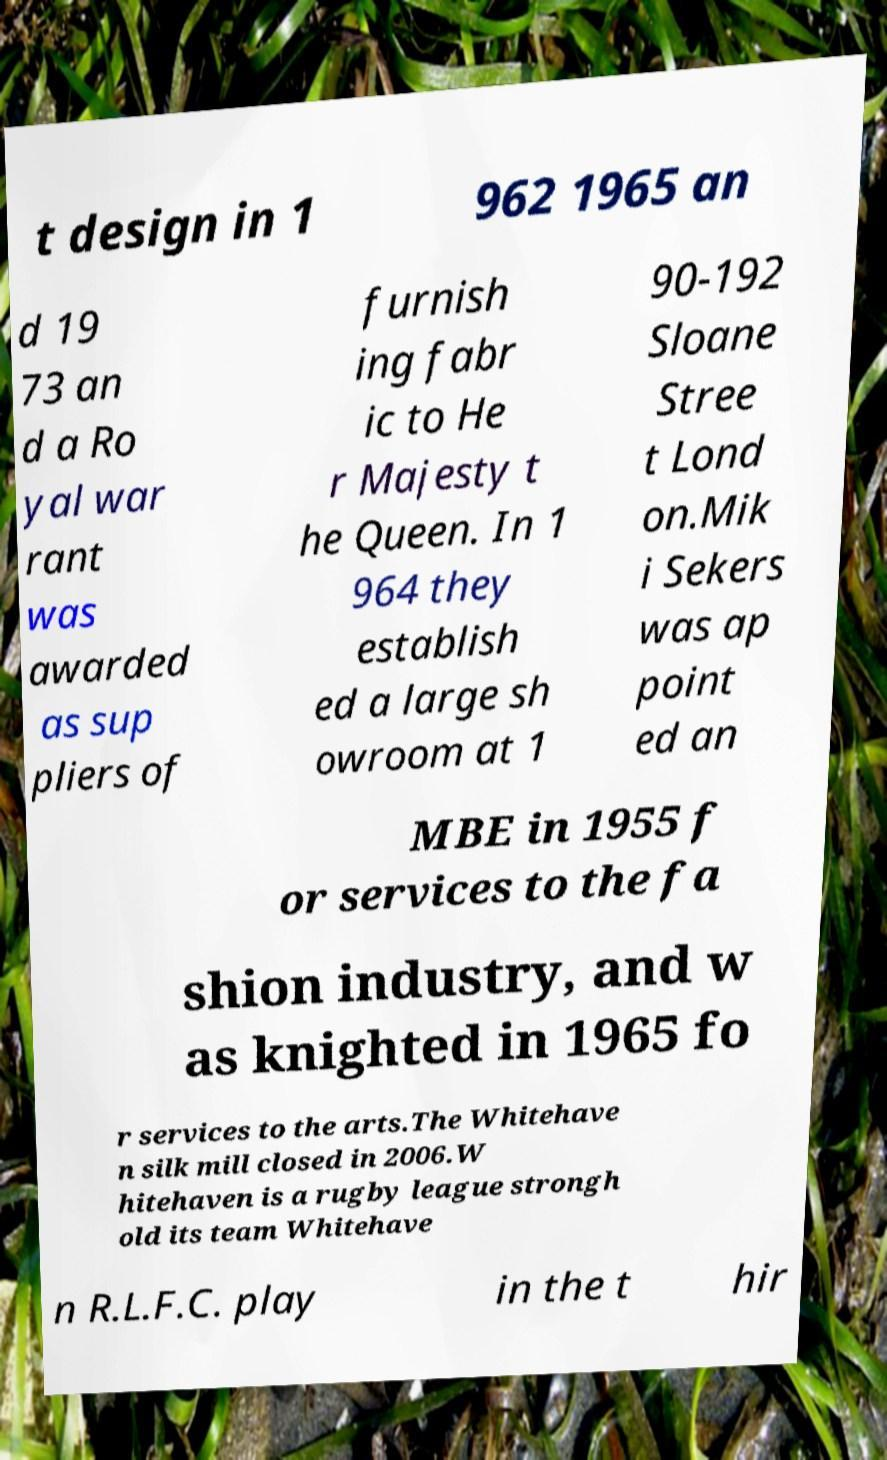Please read and relay the text visible in this image. What does it say? t design in 1 962 1965 an d 19 73 an d a Ro yal war rant was awarded as sup pliers of furnish ing fabr ic to He r Majesty t he Queen. In 1 964 they establish ed a large sh owroom at 1 90-192 Sloane Stree t Lond on.Mik i Sekers was ap point ed an MBE in 1955 f or services to the fa shion industry, and w as knighted in 1965 fo r services to the arts.The Whitehave n silk mill closed in 2006.W hitehaven is a rugby league strongh old its team Whitehave n R.L.F.C. play in the t hir 